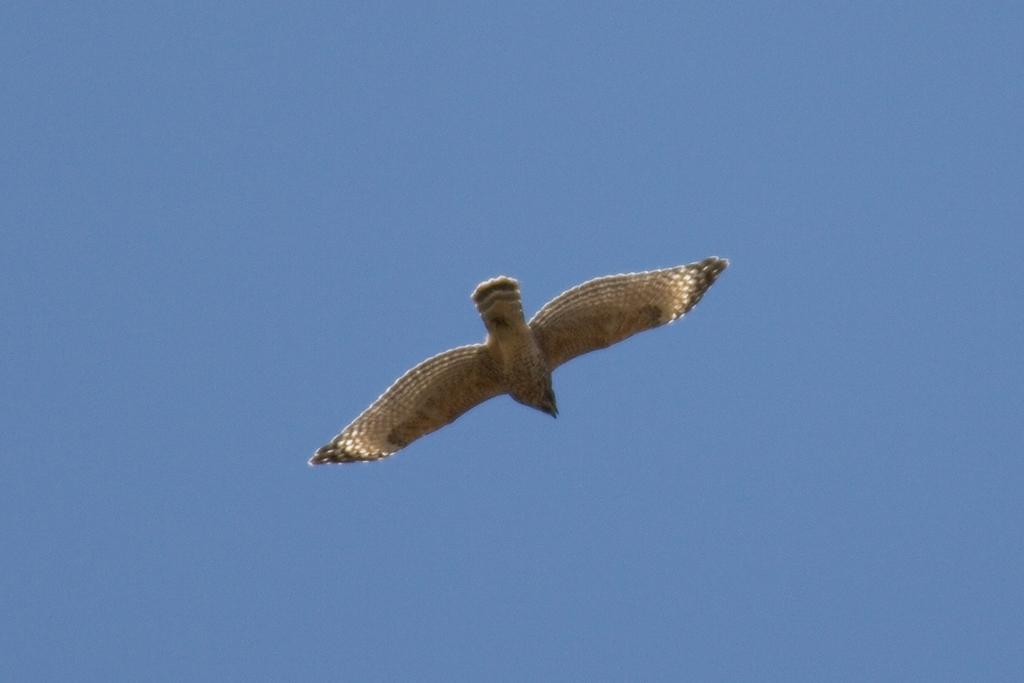Could you give a brief overview of what you see in this image? Here I can see a bird flying in the air. In the background, I can see the sky in blue color. 